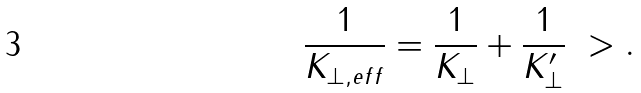Convert formula to latex. <formula><loc_0><loc_0><loc_500><loc_500>\frac { 1 } { K _ { \perp , e f f } } = \frac { 1 } { K _ { \perp } } + \frac { 1 } { K _ { \perp } ^ { \prime } } \ > .</formula> 